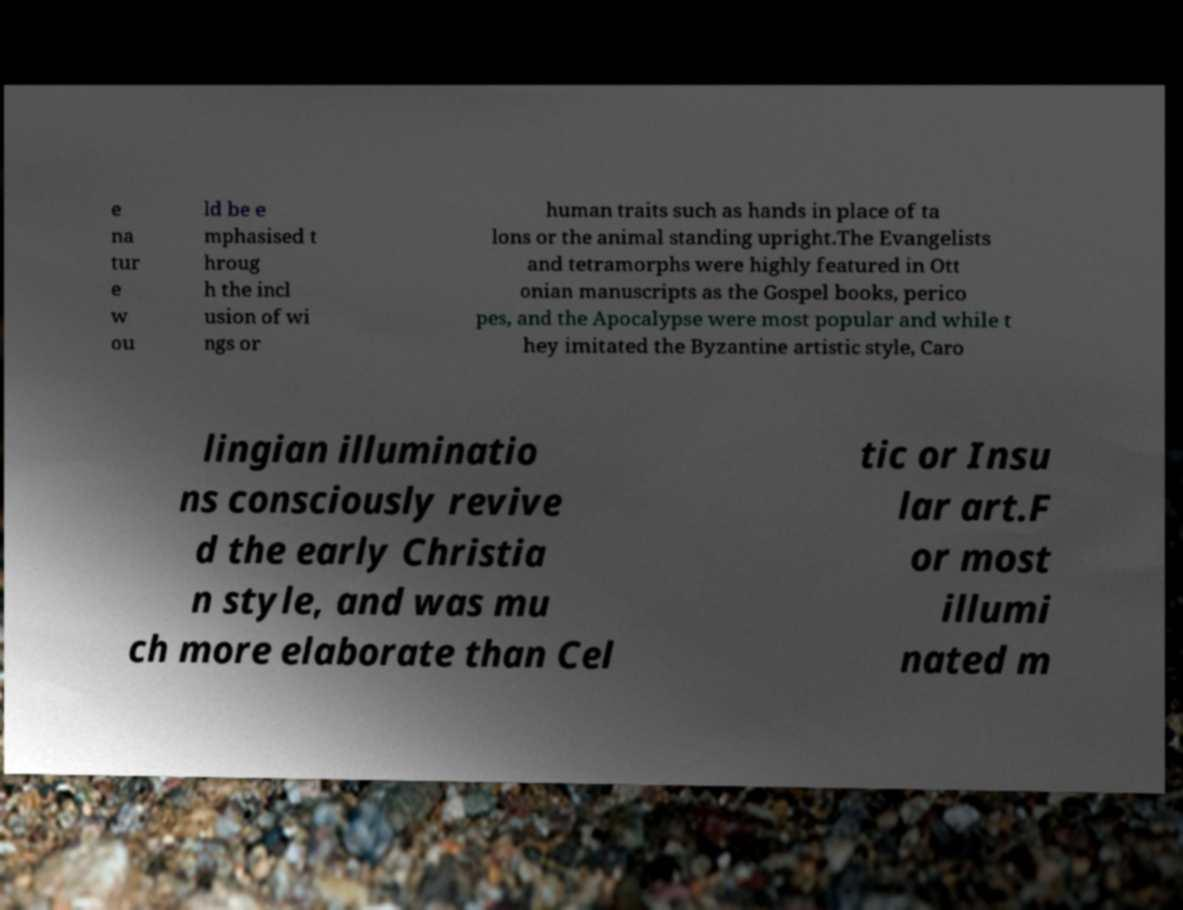Please read and relay the text visible in this image. What does it say? e na tur e w ou ld be e mphasised t hroug h the incl usion of wi ngs or human traits such as hands in place of ta lons or the animal standing upright.The Evangelists and tetramorphs were highly featured in Ott onian manuscripts as the Gospel books, perico pes, and the Apocalypse were most popular and while t hey imitated the Byzantine artistic style, Caro lingian illuminatio ns consciously revive d the early Christia n style, and was mu ch more elaborate than Cel tic or Insu lar art.F or most illumi nated m 